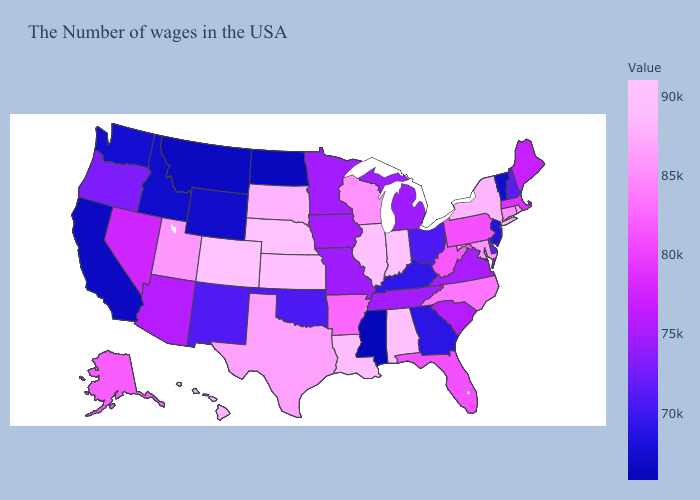Does Hawaii have the highest value in the USA?
Be succinct. No. Does New York have the highest value in the Northeast?
Answer briefly. Yes. 